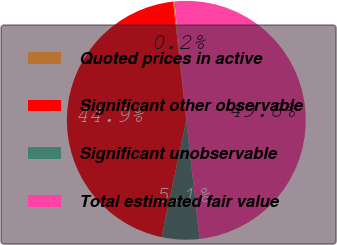Convert chart to OTSL. <chart><loc_0><loc_0><loc_500><loc_500><pie_chart><fcel>Quoted prices in active<fcel>Significant other observable<fcel>Significant unobservable<fcel>Total estimated fair value<nl><fcel>0.19%<fcel>44.9%<fcel>5.1%<fcel>49.81%<nl></chart> 